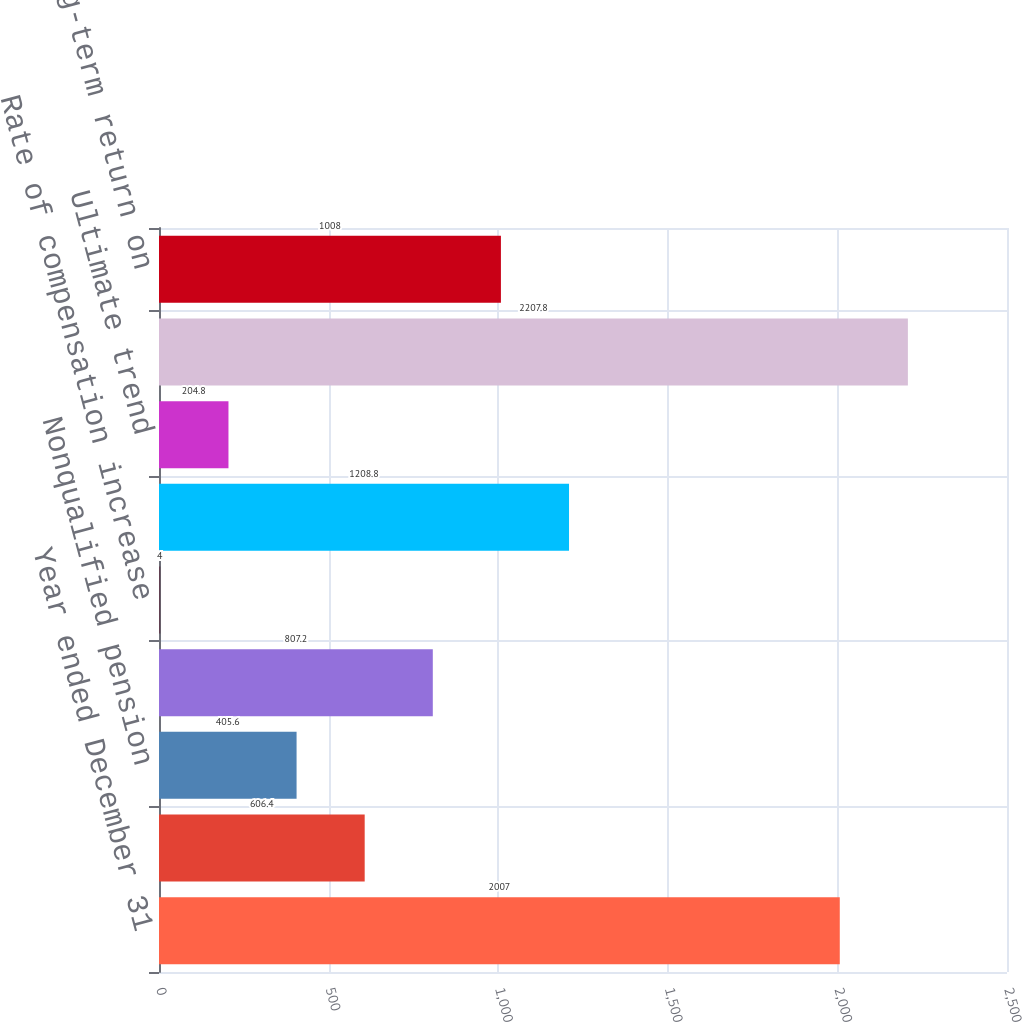<chart> <loc_0><loc_0><loc_500><loc_500><bar_chart><fcel>Year ended December 31<fcel>Qualified pension<fcel>Nonqualified pension<fcel>Postretirement benefits<fcel>Rate of compensation increase<fcel>Initial trend<fcel>Ultimate trend<fcel>Year ultimate reached<fcel>Expected long-term return on<nl><fcel>2007<fcel>606.4<fcel>405.6<fcel>807.2<fcel>4<fcel>1208.8<fcel>204.8<fcel>2207.8<fcel>1008<nl></chart> 